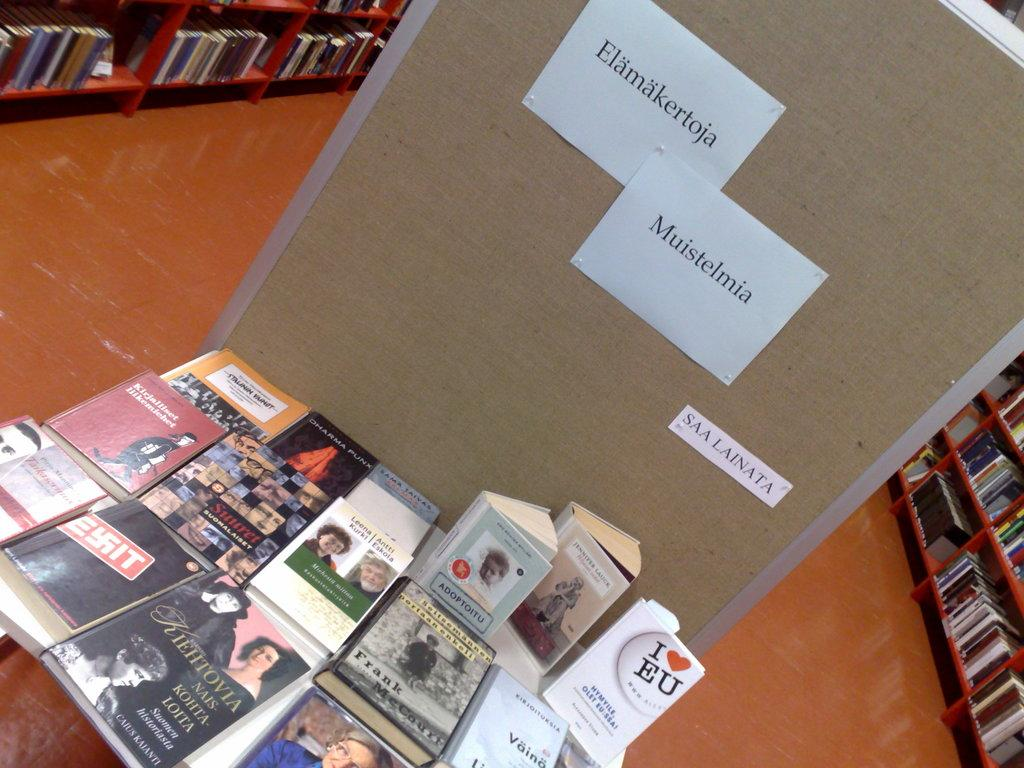What type of objects can be seen in the image? There are books and papers on a board in the image. How are the books organized in the image? The books are in racks in the image. Can you describe the papers on the board? The papers are on a board in the image. What is the value of the line drawn on the wrist of the person in the image? There is no person or line drawn on a wrist in the image. 